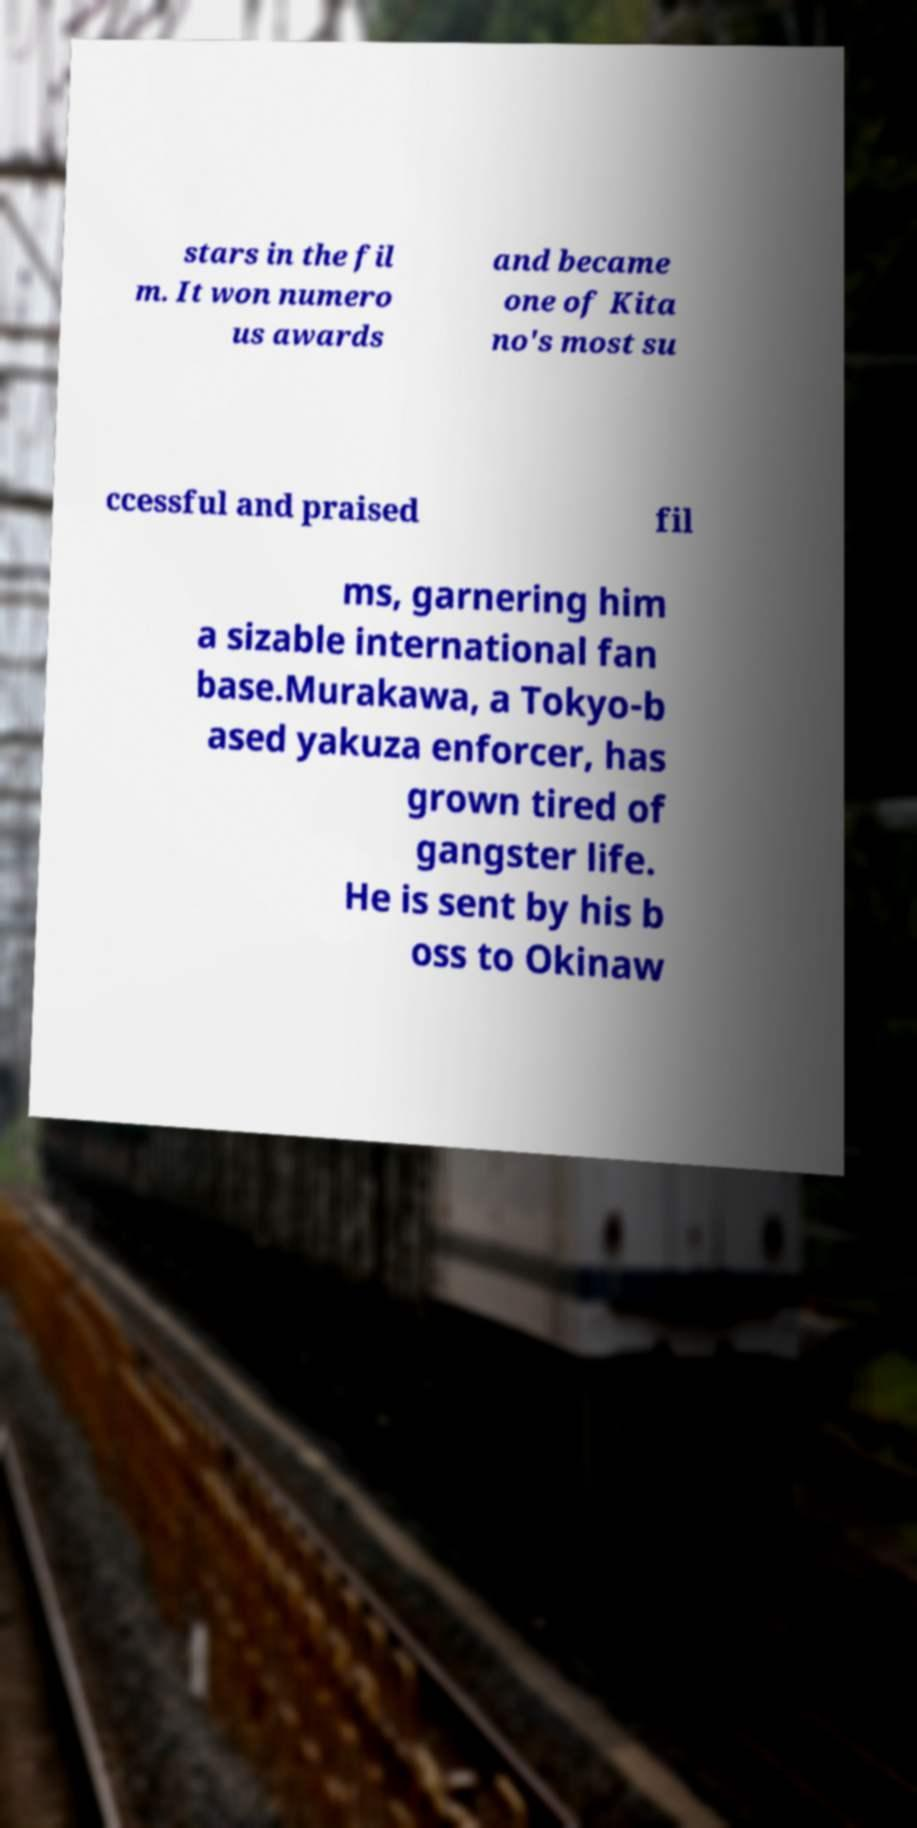For documentation purposes, I need the text within this image transcribed. Could you provide that? stars in the fil m. It won numero us awards and became one of Kita no's most su ccessful and praised fil ms, garnering him a sizable international fan base.Murakawa, a Tokyo-b ased yakuza enforcer, has grown tired of gangster life. He is sent by his b oss to Okinaw 